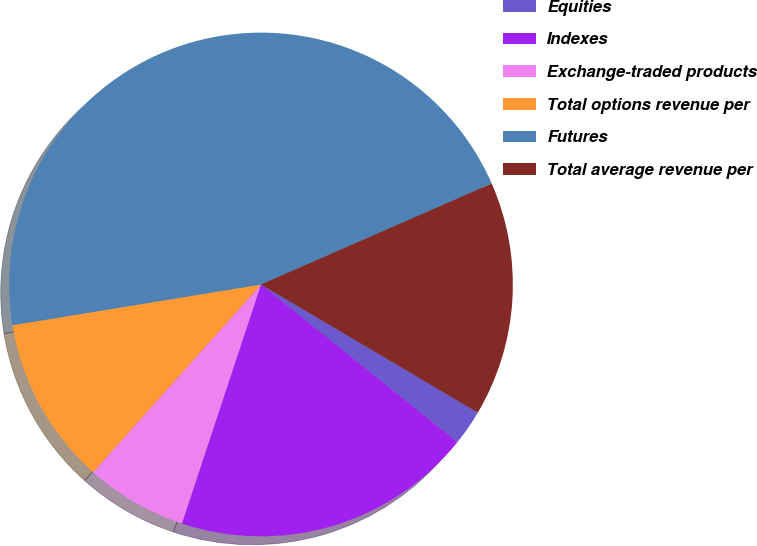Convert chart. <chart><loc_0><loc_0><loc_500><loc_500><pie_chart><fcel>Equities<fcel>Indexes<fcel>Exchange-traded products<fcel>Total options revenue per<fcel>Futures<fcel>Total average revenue per<nl><fcel>2.27%<fcel>19.32%<fcel>6.53%<fcel>10.8%<fcel>46.02%<fcel>15.06%<nl></chart> 